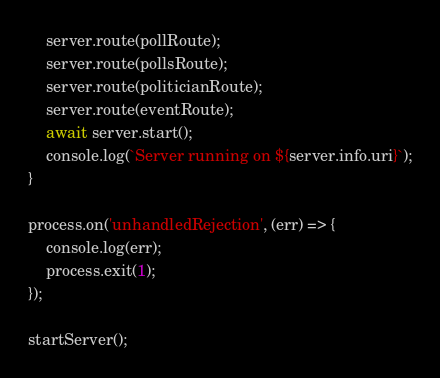Convert code to text. <code><loc_0><loc_0><loc_500><loc_500><_JavaScript_>	server.route(pollRoute);
	server.route(pollsRoute);
	server.route(politicianRoute);
	server.route(eventRoute);
	await server.start();
	console.log(`Server running on ${server.info.uri}`);
}

process.on('unhandledRejection', (err) => {
	console.log(err);
	process.exit(1);
});

startServer();
</code> 